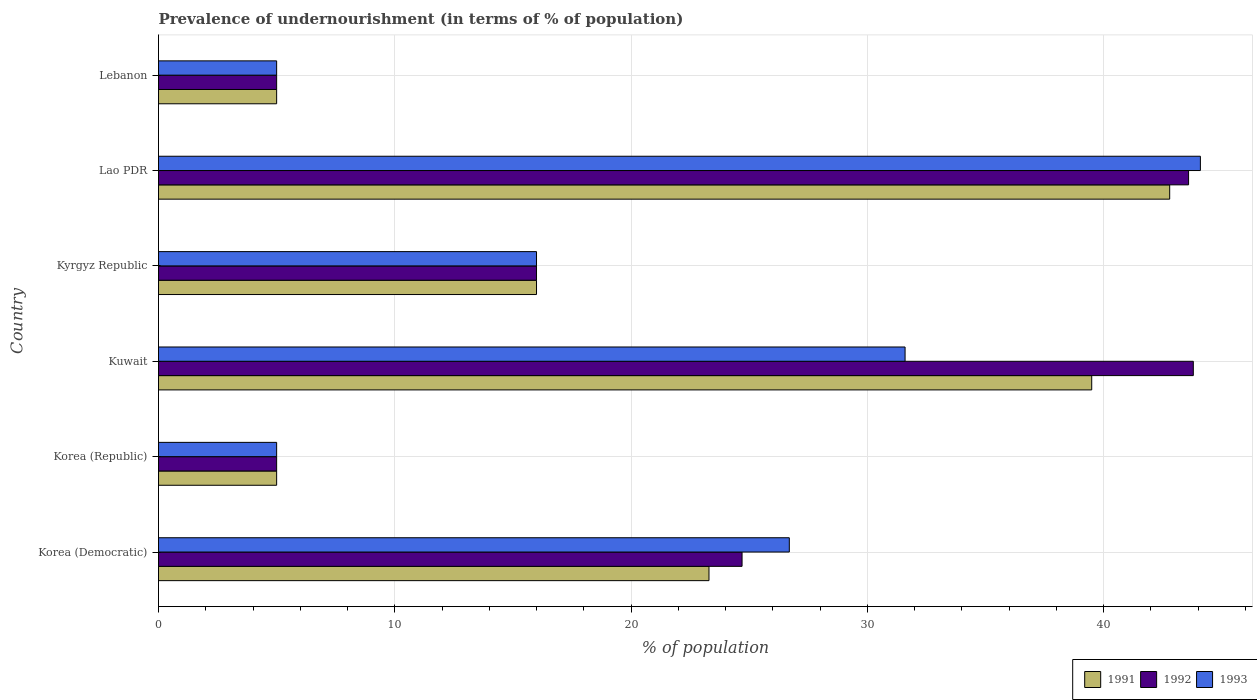Are the number of bars on each tick of the Y-axis equal?
Your response must be concise. Yes. How many bars are there on the 6th tick from the top?
Offer a very short reply. 3. How many bars are there on the 5th tick from the bottom?
Your answer should be very brief. 3. What is the label of the 4th group of bars from the top?
Give a very brief answer. Kuwait. In how many cases, is the number of bars for a given country not equal to the number of legend labels?
Provide a short and direct response. 0. Across all countries, what is the maximum percentage of undernourished population in 1992?
Make the answer very short. 43.8. Across all countries, what is the minimum percentage of undernourished population in 1993?
Your response must be concise. 5. In which country was the percentage of undernourished population in 1991 maximum?
Provide a succinct answer. Lao PDR. What is the total percentage of undernourished population in 1993 in the graph?
Keep it short and to the point. 128.4. What is the difference between the percentage of undernourished population in 1991 in Kyrgyz Republic and that in Lebanon?
Keep it short and to the point. 11. What is the difference between the percentage of undernourished population in 1992 in Korea (Democratic) and the percentage of undernourished population in 1991 in Korea (Republic)?
Provide a succinct answer. 19.7. What is the average percentage of undernourished population in 1991 per country?
Offer a very short reply. 21.93. What is the ratio of the percentage of undernourished population in 1993 in Korea (Republic) to that in Kuwait?
Your answer should be very brief. 0.16. What is the difference between the highest and the second highest percentage of undernourished population in 1993?
Provide a short and direct response. 12.5. What is the difference between the highest and the lowest percentage of undernourished population in 1992?
Your response must be concise. 38.8. How many bars are there?
Offer a very short reply. 18. How many legend labels are there?
Make the answer very short. 3. What is the title of the graph?
Offer a terse response. Prevalence of undernourishment (in terms of % of population). Does "1976" appear as one of the legend labels in the graph?
Give a very brief answer. No. What is the label or title of the X-axis?
Provide a succinct answer. % of population. What is the % of population of 1991 in Korea (Democratic)?
Your answer should be compact. 23.3. What is the % of population in 1992 in Korea (Democratic)?
Make the answer very short. 24.7. What is the % of population of 1993 in Korea (Democratic)?
Keep it short and to the point. 26.7. What is the % of population of 1991 in Korea (Republic)?
Keep it short and to the point. 5. What is the % of population of 1991 in Kuwait?
Your answer should be very brief. 39.5. What is the % of population in 1992 in Kuwait?
Provide a short and direct response. 43.8. What is the % of population of 1993 in Kuwait?
Make the answer very short. 31.6. What is the % of population of 1991 in Kyrgyz Republic?
Offer a terse response. 16. What is the % of population of 1992 in Kyrgyz Republic?
Offer a terse response. 16. What is the % of population of 1993 in Kyrgyz Republic?
Offer a very short reply. 16. What is the % of population in 1991 in Lao PDR?
Provide a succinct answer. 42.8. What is the % of population of 1992 in Lao PDR?
Keep it short and to the point. 43.6. What is the % of population of 1993 in Lao PDR?
Offer a terse response. 44.1. What is the % of population of 1993 in Lebanon?
Offer a very short reply. 5. Across all countries, what is the maximum % of population in 1991?
Make the answer very short. 42.8. Across all countries, what is the maximum % of population in 1992?
Provide a succinct answer. 43.8. Across all countries, what is the maximum % of population of 1993?
Your answer should be very brief. 44.1. Across all countries, what is the minimum % of population of 1992?
Ensure brevity in your answer.  5. What is the total % of population of 1991 in the graph?
Give a very brief answer. 131.6. What is the total % of population in 1992 in the graph?
Ensure brevity in your answer.  138.1. What is the total % of population of 1993 in the graph?
Give a very brief answer. 128.4. What is the difference between the % of population in 1993 in Korea (Democratic) and that in Korea (Republic)?
Your answer should be very brief. 21.7. What is the difference between the % of population of 1991 in Korea (Democratic) and that in Kuwait?
Ensure brevity in your answer.  -16.2. What is the difference between the % of population in 1992 in Korea (Democratic) and that in Kuwait?
Offer a terse response. -19.1. What is the difference between the % of population in 1993 in Korea (Democratic) and that in Kuwait?
Your answer should be very brief. -4.9. What is the difference between the % of population of 1993 in Korea (Democratic) and that in Kyrgyz Republic?
Your answer should be very brief. 10.7. What is the difference between the % of population in 1991 in Korea (Democratic) and that in Lao PDR?
Provide a succinct answer. -19.5. What is the difference between the % of population in 1992 in Korea (Democratic) and that in Lao PDR?
Your answer should be very brief. -18.9. What is the difference between the % of population of 1993 in Korea (Democratic) and that in Lao PDR?
Make the answer very short. -17.4. What is the difference between the % of population in 1993 in Korea (Democratic) and that in Lebanon?
Your answer should be very brief. 21.7. What is the difference between the % of population of 1991 in Korea (Republic) and that in Kuwait?
Your response must be concise. -34.5. What is the difference between the % of population in 1992 in Korea (Republic) and that in Kuwait?
Offer a very short reply. -38.8. What is the difference between the % of population in 1993 in Korea (Republic) and that in Kuwait?
Provide a succinct answer. -26.6. What is the difference between the % of population of 1991 in Korea (Republic) and that in Kyrgyz Republic?
Provide a succinct answer. -11. What is the difference between the % of population in 1991 in Korea (Republic) and that in Lao PDR?
Offer a very short reply. -37.8. What is the difference between the % of population of 1992 in Korea (Republic) and that in Lao PDR?
Give a very brief answer. -38.6. What is the difference between the % of population in 1993 in Korea (Republic) and that in Lao PDR?
Provide a short and direct response. -39.1. What is the difference between the % of population in 1991 in Korea (Republic) and that in Lebanon?
Provide a succinct answer. 0. What is the difference between the % of population in 1992 in Korea (Republic) and that in Lebanon?
Your answer should be compact. 0. What is the difference between the % of population in 1992 in Kuwait and that in Kyrgyz Republic?
Give a very brief answer. 27.8. What is the difference between the % of population in 1993 in Kuwait and that in Kyrgyz Republic?
Your answer should be very brief. 15.6. What is the difference between the % of population of 1991 in Kuwait and that in Lebanon?
Keep it short and to the point. 34.5. What is the difference between the % of population of 1992 in Kuwait and that in Lebanon?
Provide a short and direct response. 38.8. What is the difference between the % of population of 1993 in Kuwait and that in Lebanon?
Your response must be concise. 26.6. What is the difference between the % of population of 1991 in Kyrgyz Republic and that in Lao PDR?
Provide a short and direct response. -26.8. What is the difference between the % of population in 1992 in Kyrgyz Republic and that in Lao PDR?
Provide a short and direct response. -27.6. What is the difference between the % of population in 1993 in Kyrgyz Republic and that in Lao PDR?
Ensure brevity in your answer.  -28.1. What is the difference between the % of population in 1991 in Lao PDR and that in Lebanon?
Your answer should be compact. 37.8. What is the difference between the % of population of 1992 in Lao PDR and that in Lebanon?
Provide a short and direct response. 38.6. What is the difference between the % of population of 1993 in Lao PDR and that in Lebanon?
Your answer should be compact. 39.1. What is the difference between the % of population in 1991 in Korea (Democratic) and the % of population in 1992 in Korea (Republic)?
Give a very brief answer. 18.3. What is the difference between the % of population in 1991 in Korea (Democratic) and the % of population in 1992 in Kuwait?
Your answer should be compact. -20.5. What is the difference between the % of population in 1991 in Korea (Democratic) and the % of population in 1993 in Kuwait?
Ensure brevity in your answer.  -8.3. What is the difference between the % of population in 1991 in Korea (Democratic) and the % of population in 1993 in Kyrgyz Republic?
Ensure brevity in your answer.  7.3. What is the difference between the % of population of 1992 in Korea (Democratic) and the % of population of 1993 in Kyrgyz Republic?
Provide a succinct answer. 8.7. What is the difference between the % of population of 1991 in Korea (Democratic) and the % of population of 1992 in Lao PDR?
Your answer should be very brief. -20.3. What is the difference between the % of population in 1991 in Korea (Democratic) and the % of population in 1993 in Lao PDR?
Offer a very short reply. -20.8. What is the difference between the % of population of 1992 in Korea (Democratic) and the % of population of 1993 in Lao PDR?
Give a very brief answer. -19.4. What is the difference between the % of population of 1991 in Korea (Democratic) and the % of population of 1992 in Lebanon?
Keep it short and to the point. 18.3. What is the difference between the % of population of 1991 in Korea (Democratic) and the % of population of 1993 in Lebanon?
Provide a short and direct response. 18.3. What is the difference between the % of population in 1991 in Korea (Republic) and the % of population in 1992 in Kuwait?
Your response must be concise. -38.8. What is the difference between the % of population in 1991 in Korea (Republic) and the % of population in 1993 in Kuwait?
Your response must be concise. -26.6. What is the difference between the % of population of 1992 in Korea (Republic) and the % of population of 1993 in Kuwait?
Provide a short and direct response. -26.6. What is the difference between the % of population of 1992 in Korea (Republic) and the % of population of 1993 in Kyrgyz Republic?
Make the answer very short. -11. What is the difference between the % of population in 1991 in Korea (Republic) and the % of population in 1992 in Lao PDR?
Provide a short and direct response. -38.6. What is the difference between the % of population in 1991 in Korea (Republic) and the % of population in 1993 in Lao PDR?
Your answer should be compact. -39.1. What is the difference between the % of population in 1992 in Korea (Republic) and the % of population in 1993 in Lao PDR?
Offer a terse response. -39.1. What is the difference between the % of population of 1991 in Korea (Republic) and the % of population of 1992 in Lebanon?
Your response must be concise. 0. What is the difference between the % of population of 1991 in Kuwait and the % of population of 1993 in Kyrgyz Republic?
Offer a very short reply. 23.5. What is the difference between the % of population in 1992 in Kuwait and the % of population in 1993 in Kyrgyz Republic?
Your answer should be compact. 27.8. What is the difference between the % of population in 1991 in Kuwait and the % of population in 1992 in Lao PDR?
Offer a very short reply. -4.1. What is the difference between the % of population of 1991 in Kuwait and the % of population of 1993 in Lao PDR?
Offer a terse response. -4.6. What is the difference between the % of population in 1992 in Kuwait and the % of population in 1993 in Lao PDR?
Ensure brevity in your answer.  -0.3. What is the difference between the % of population of 1991 in Kuwait and the % of population of 1992 in Lebanon?
Your response must be concise. 34.5. What is the difference between the % of population of 1991 in Kuwait and the % of population of 1993 in Lebanon?
Give a very brief answer. 34.5. What is the difference between the % of population in 1992 in Kuwait and the % of population in 1993 in Lebanon?
Offer a terse response. 38.8. What is the difference between the % of population in 1991 in Kyrgyz Republic and the % of population in 1992 in Lao PDR?
Provide a short and direct response. -27.6. What is the difference between the % of population in 1991 in Kyrgyz Republic and the % of population in 1993 in Lao PDR?
Your answer should be compact. -28.1. What is the difference between the % of population of 1992 in Kyrgyz Republic and the % of population of 1993 in Lao PDR?
Your answer should be very brief. -28.1. What is the difference between the % of population in 1991 in Kyrgyz Republic and the % of population in 1992 in Lebanon?
Give a very brief answer. 11. What is the difference between the % of population in 1991 in Lao PDR and the % of population in 1992 in Lebanon?
Make the answer very short. 37.8. What is the difference between the % of population of 1991 in Lao PDR and the % of population of 1993 in Lebanon?
Give a very brief answer. 37.8. What is the difference between the % of population in 1992 in Lao PDR and the % of population in 1993 in Lebanon?
Your answer should be compact. 38.6. What is the average % of population in 1991 per country?
Your response must be concise. 21.93. What is the average % of population of 1992 per country?
Keep it short and to the point. 23.02. What is the average % of population of 1993 per country?
Your response must be concise. 21.4. What is the difference between the % of population in 1991 and % of population in 1992 in Korea (Democratic)?
Make the answer very short. -1.4. What is the difference between the % of population in 1992 and % of population in 1993 in Korea (Republic)?
Your response must be concise. 0. What is the difference between the % of population of 1991 and % of population of 1992 in Kuwait?
Your answer should be very brief. -4.3. What is the difference between the % of population in 1991 and % of population in 1993 in Kuwait?
Keep it short and to the point. 7.9. What is the difference between the % of population in 1991 and % of population in 1992 in Kyrgyz Republic?
Your answer should be compact. 0. What is the difference between the % of population in 1991 and % of population in 1992 in Lao PDR?
Provide a short and direct response. -0.8. What is the difference between the % of population of 1991 and % of population of 1993 in Lao PDR?
Your answer should be compact. -1.3. What is the difference between the % of population in 1992 and % of population in 1993 in Lebanon?
Provide a short and direct response. 0. What is the ratio of the % of population in 1991 in Korea (Democratic) to that in Korea (Republic)?
Your response must be concise. 4.66. What is the ratio of the % of population of 1992 in Korea (Democratic) to that in Korea (Republic)?
Give a very brief answer. 4.94. What is the ratio of the % of population in 1993 in Korea (Democratic) to that in Korea (Republic)?
Your answer should be very brief. 5.34. What is the ratio of the % of population of 1991 in Korea (Democratic) to that in Kuwait?
Provide a short and direct response. 0.59. What is the ratio of the % of population in 1992 in Korea (Democratic) to that in Kuwait?
Your answer should be compact. 0.56. What is the ratio of the % of population in 1993 in Korea (Democratic) to that in Kuwait?
Keep it short and to the point. 0.84. What is the ratio of the % of population of 1991 in Korea (Democratic) to that in Kyrgyz Republic?
Your response must be concise. 1.46. What is the ratio of the % of population in 1992 in Korea (Democratic) to that in Kyrgyz Republic?
Give a very brief answer. 1.54. What is the ratio of the % of population in 1993 in Korea (Democratic) to that in Kyrgyz Republic?
Your answer should be very brief. 1.67. What is the ratio of the % of population in 1991 in Korea (Democratic) to that in Lao PDR?
Keep it short and to the point. 0.54. What is the ratio of the % of population in 1992 in Korea (Democratic) to that in Lao PDR?
Your response must be concise. 0.57. What is the ratio of the % of population of 1993 in Korea (Democratic) to that in Lao PDR?
Provide a succinct answer. 0.61. What is the ratio of the % of population of 1991 in Korea (Democratic) to that in Lebanon?
Keep it short and to the point. 4.66. What is the ratio of the % of population in 1992 in Korea (Democratic) to that in Lebanon?
Ensure brevity in your answer.  4.94. What is the ratio of the % of population in 1993 in Korea (Democratic) to that in Lebanon?
Ensure brevity in your answer.  5.34. What is the ratio of the % of population of 1991 in Korea (Republic) to that in Kuwait?
Give a very brief answer. 0.13. What is the ratio of the % of population of 1992 in Korea (Republic) to that in Kuwait?
Offer a terse response. 0.11. What is the ratio of the % of population of 1993 in Korea (Republic) to that in Kuwait?
Keep it short and to the point. 0.16. What is the ratio of the % of population of 1991 in Korea (Republic) to that in Kyrgyz Republic?
Ensure brevity in your answer.  0.31. What is the ratio of the % of population in 1992 in Korea (Republic) to that in Kyrgyz Republic?
Your response must be concise. 0.31. What is the ratio of the % of population in 1993 in Korea (Republic) to that in Kyrgyz Republic?
Offer a very short reply. 0.31. What is the ratio of the % of population of 1991 in Korea (Republic) to that in Lao PDR?
Provide a succinct answer. 0.12. What is the ratio of the % of population in 1992 in Korea (Republic) to that in Lao PDR?
Offer a very short reply. 0.11. What is the ratio of the % of population in 1993 in Korea (Republic) to that in Lao PDR?
Your answer should be compact. 0.11. What is the ratio of the % of population of 1992 in Korea (Republic) to that in Lebanon?
Give a very brief answer. 1. What is the ratio of the % of population in 1991 in Kuwait to that in Kyrgyz Republic?
Your answer should be compact. 2.47. What is the ratio of the % of population in 1992 in Kuwait to that in Kyrgyz Republic?
Keep it short and to the point. 2.74. What is the ratio of the % of population in 1993 in Kuwait to that in Kyrgyz Republic?
Your answer should be compact. 1.98. What is the ratio of the % of population of 1991 in Kuwait to that in Lao PDR?
Provide a short and direct response. 0.92. What is the ratio of the % of population in 1992 in Kuwait to that in Lao PDR?
Offer a terse response. 1. What is the ratio of the % of population in 1993 in Kuwait to that in Lao PDR?
Keep it short and to the point. 0.72. What is the ratio of the % of population of 1991 in Kuwait to that in Lebanon?
Provide a short and direct response. 7.9. What is the ratio of the % of population in 1992 in Kuwait to that in Lebanon?
Give a very brief answer. 8.76. What is the ratio of the % of population in 1993 in Kuwait to that in Lebanon?
Offer a terse response. 6.32. What is the ratio of the % of population in 1991 in Kyrgyz Republic to that in Lao PDR?
Make the answer very short. 0.37. What is the ratio of the % of population of 1992 in Kyrgyz Republic to that in Lao PDR?
Provide a short and direct response. 0.37. What is the ratio of the % of population in 1993 in Kyrgyz Republic to that in Lao PDR?
Your answer should be compact. 0.36. What is the ratio of the % of population in 1992 in Kyrgyz Republic to that in Lebanon?
Your answer should be very brief. 3.2. What is the ratio of the % of population in 1991 in Lao PDR to that in Lebanon?
Your answer should be compact. 8.56. What is the ratio of the % of population of 1992 in Lao PDR to that in Lebanon?
Ensure brevity in your answer.  8.72. What is the ratio of the % of population of 1993 in Lao PDR to that in Lebanon?
Ensure brevity in your answer.  8.82. What is the difference between the highest and the lowest % of population of 1991?
Ensure brevity in your answer.  37.8. What is the difference between the highest and the lowest % of population of 1992?
Offer a very short reply. 38.8. What is the difference between the highest and the lowest % of population in 1993?
Ensure brevity in your answer.  39.1. 